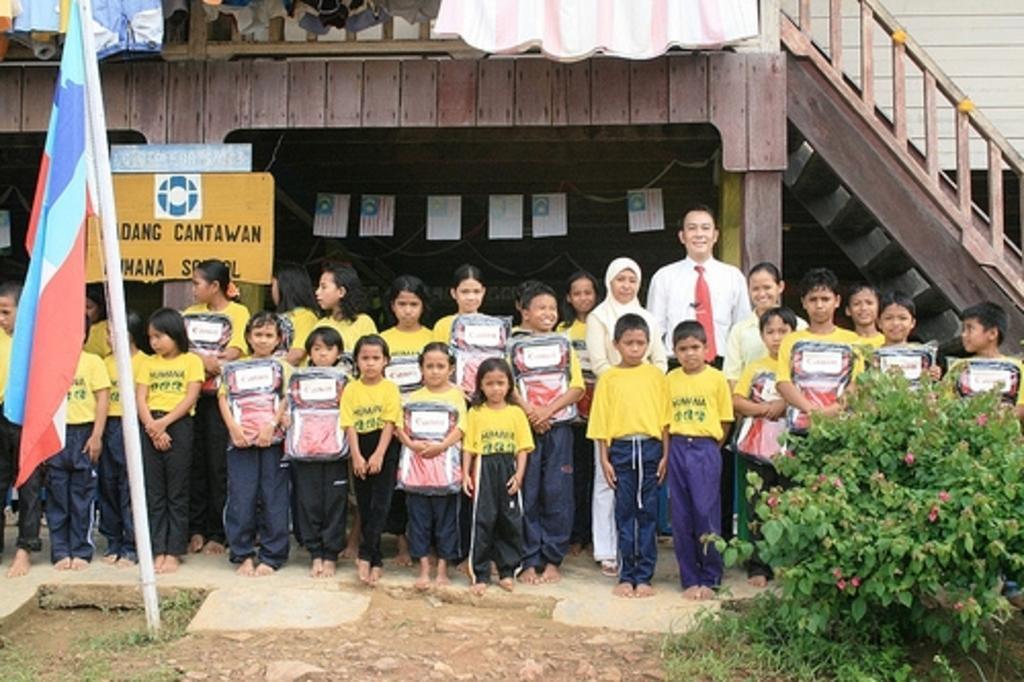In one or two sentences, can you explain what this image depicts? In the picture I can see children wearing yellow color T-shirts are holding some objects and standing here and we can see a woman and man are also standing. Here we can see planets on the right side of the image and the flag on the left side of the image. In the background, I can see boards, wooden wall and steps. 